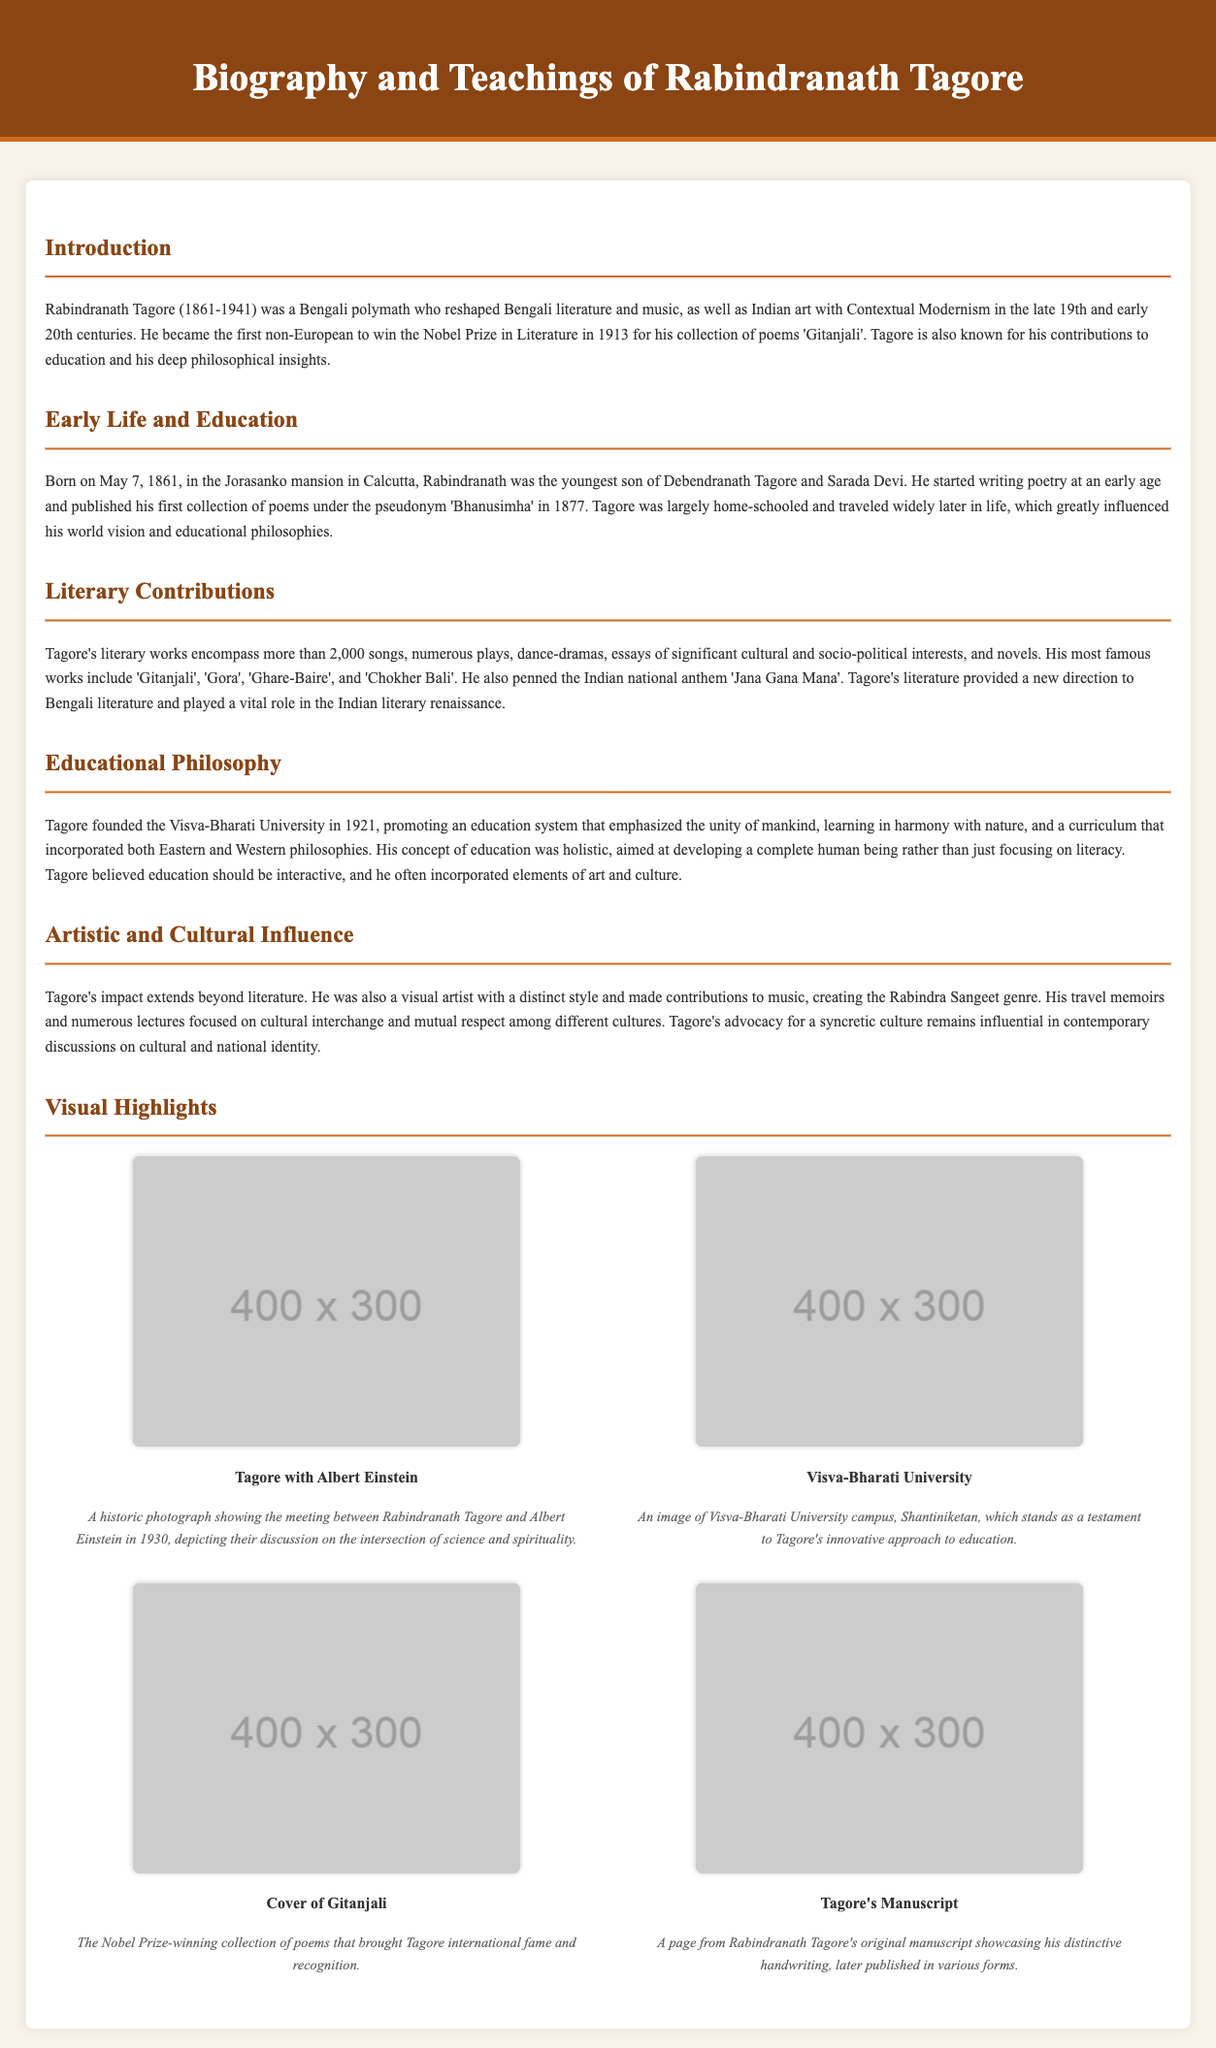What year was Rabindranath Tagore born? The document states that Rabindranath Tagore was born on May 7, 1861.
Answer: 1861 What is the title of Tagore's collection of poems that won him the Nobel Prize? The document mentions that he won the Nobel Prize in Literature in 1913 for his collection of poems 'Gitanjali'.
Answer: Gitanjali What educational institution did Tagore found in 1921? The document notes that Tagore founded the Visva-Bharati University in 1921.
Answer: Visva-Bharati University Who did Tagore discuss with in 1930 according to the visual highlight? The document indicates that Tagore had a historic photograph with Albert Einstein.
Answer: Albert Einstein What type of art did Tagore contribute to besides literature? The document states that Tagore made contributions to music, creating the Rabindra Sangeet genre.
Answer: Music What is a key concept of Tagore's educational philosophy? The document explains that Tagore emphasized the unity of mankind and holistic education.
Answer: Unity of mankind How many songs did Tagore's literary works encompass? The document specifies that Tagore's literary works encompass more than 2,000 songs.
Answer: 2,000 What year did Tagore win the Nobel Prize in Literature? The document mentions that Tagore won the Nobel Prize in Literature in 1913.
Answer: 1913 What does the image of Visva-Bharati University represent? The document states that it stands as a testament to Tagore's innovative approach to education.
Answer: Innovative approach to education 